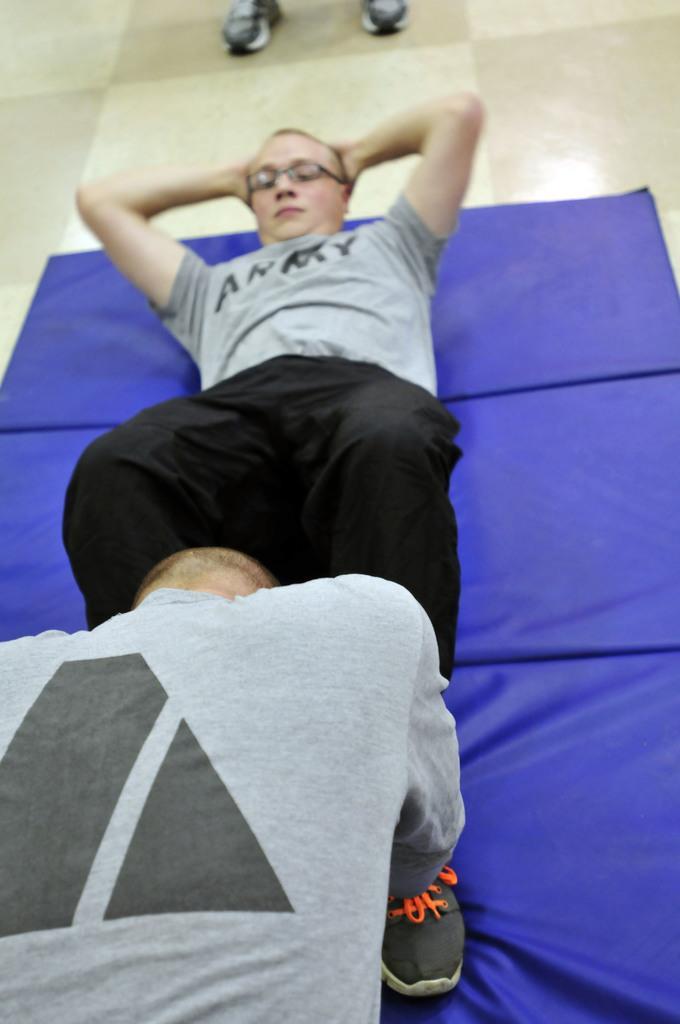Could you give a brief overview of what you see in this image? In the center of the image we can see two people doing exercises. At the bottom there is a mat placed on the floor. 